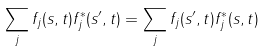<formula> <loc_0><loc_0><loc_500><loc_500>\sum _ { j } f _ { j } ( s , t ) f _ { j } ^ { * } ( s ^ { \prime } , t ) = \sum _ { j } f _ { j } ( s ^ { \prime } , t ) f _ { j } ^ { * } ( s , t )</formula> 